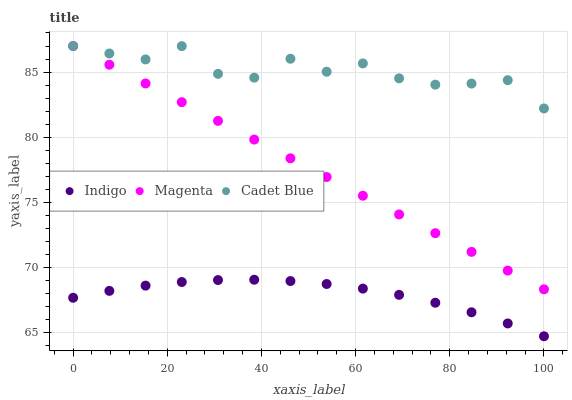Does Indigo have the minimum area under the curve?
Answer yes or no. Yes. Does Cadet Blue have the maximum area under the curve?
Answer yes or no. Yes. Does Cadet Blue have the minimum area under the curve?
Answer yes or no. No. Does Indigo have the maximum area under the curve?
Answer yes or no. No. Is Magenta the smoothest?
Answer yes or no. Yes. Is Cadet Blue the roughest?
Answer yes or no. Yes. Is Indigo the smoothest?
Answer yes or no. No. Is Indigo the roughest?
Answer yes or no. No. Does Indigo have the lowest value?
Answer yes or no. Yes. Does Cadet Blue have the lowest value?
Answer yes or no. No. Does Cadet Blue have the highest value?
Answer yes or no. Yes. Does Indigo have the highest value?
Answer yes or no. No. Is Indigo less than Cadet Blue?
Answer yes or no. Yes. Is Cadet Blue greater than Indigo?
Answer yes or no. Yes. Does Magenta intersect Cadet Blue?
Answer yes or no. Yes. Is Magenta less than Cadet Blue?
Answer yes or no. No. Is Magenta greater than Cadet Blue?
Answer yes or no. No. Does Indigo intersect Cadet Blue?
Answer yes or no. No. 